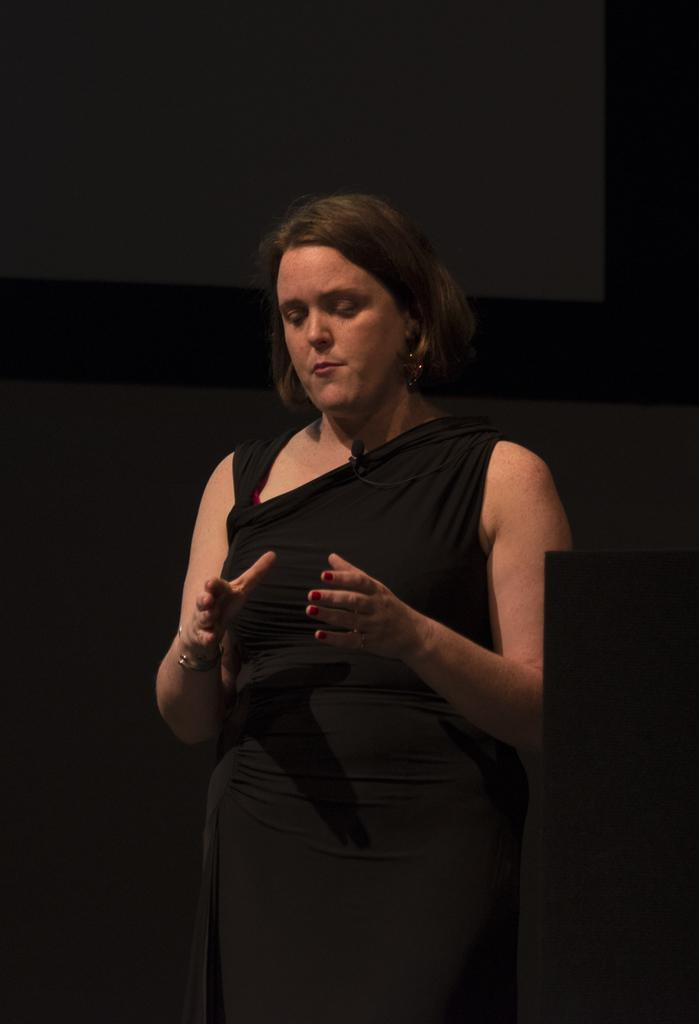What is the main subject of the image? There is a lady standing in the center of the image. What is located at the top of the image? There is a board at the top of the image. What type of structure is present in the middle of the image? There is a wall present in the middle of the image. What type of account does the lady have in the image? There is no mention of an account in the image, as it primarily features a lady standing with a board and a wall. 